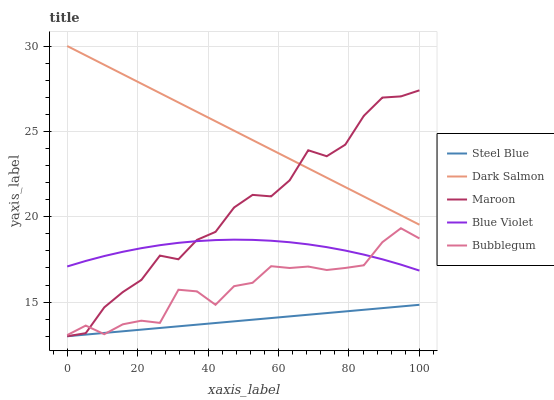Does Steel Blue have the minimum area under the curve?
Answer yes or no. Yes. Does Dark Salmon have the maximum area under the curve?
Answer yes or no. Yes. Does Bubblegum have the minimum area under the curve?
Answer yes or no. No. Does Bubblegum have the maximum area under the curve?
Answer yes or no. No. Is Steel Blue the smoothest?
Answer yes or no. Yes. Is Maroon the roughest?
Answer yes or no. Yes. Is Bubblegum the smoothest?
Answer yes or no. No. Is Bubblegum the roughest?
Answer yes or no. No. Does Steel Blue have the lowest value?
Answer yes or no. Yes. Does Bubblegum have the lowest value?
Answer yes or no. No. Does Dark Salmon have the highest value?
Answer yes or no. Yes. Does Bubblegum have the highest value?
Answer yes or no. No. Is Blue Violet less than Dark Salmon?
Answer yes or no. Yes. Is Dark Salmon greater than Blue Violet?
Answer yes or no. Yes. Does Blue Violet intersect Bubblegum?
Answer yes or no. Yes. Is Blue Violet less than Bubblegum?
Answer yes or no. No. Is Blue Violet greater than Bubblegum?
Answer yes or no. No. Does Blue Violet intersect Dark Salmon?
Answer yes or no. No. 